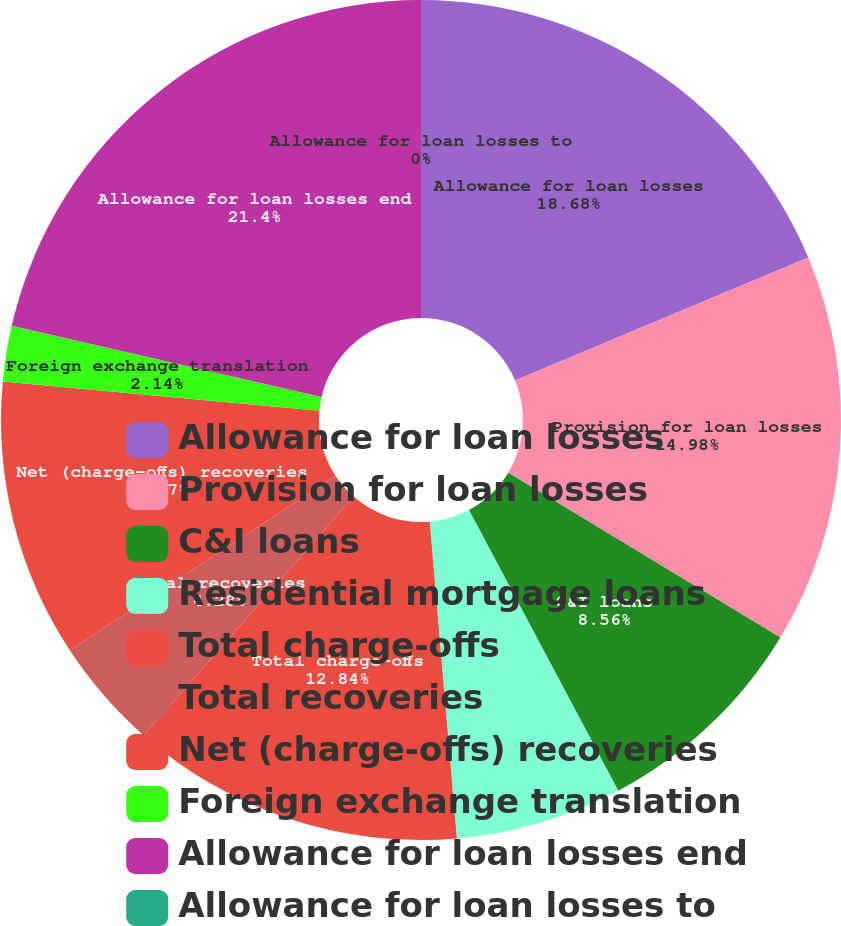Convert chart. <chart><loc_0><loc_0><loc_500><loc_500><pie_chart><fcel>Allowance for loan losses<fcel>Provision for loan losses<fcel>C&I loans<fcel>Residential mortgage loans<fcel>Total charge-offs<fcel>Total recoveries<fcel>Net (charge-offs) recoveries<fcel>Foreign exchange translation<fcel>Allowance for loan losses end<fcel>Allowance for loan losses to<nl><fcel>18.68%<fcel>14.98%<fcel>8.56%<fcel>6.42%<fcel>12.84%<fcel>4.28%<fcel>10.7%<fcel>2.14%<fcel>21.4%<fcel>0.0%<nl></chart> 